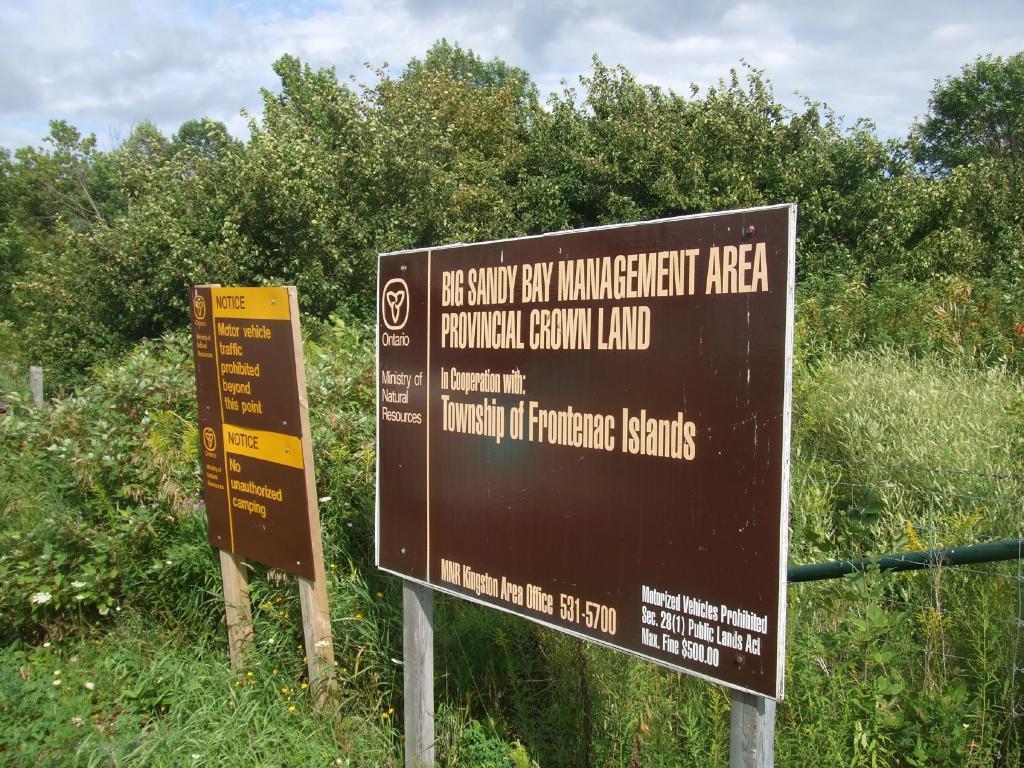Could you give a brief overview of what you see in this image? There are two advertising boards with some text in the middle of this image and there are some trees in the background. There is a sky at the top of this image,. 